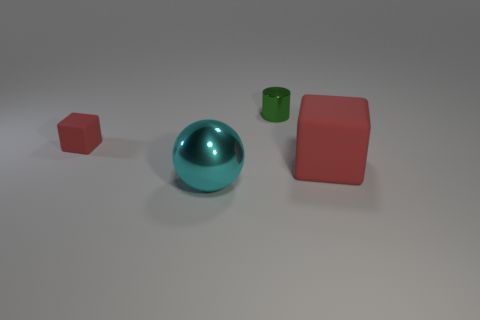Add 4 large cyan cubes. How many objects exist? 8 Subtract 1 balls. How many balls are left? 0 Subtract all cylinders. How many objects are left? 3 Subtract all blue cylinders. How many gray spheres are left? 0 Add 2 red things. How many red things exist? 4 Subtract 0 blue cubes. How many objects are left? 4 Subtract all green blocks. Subtract all brown cylinders. How many blocks are left? 2 Subtract all spheres. Subtract all rubber objects. How many objects are left? 1 Add 1 big cyan things. How many big cyan things are left? 2 